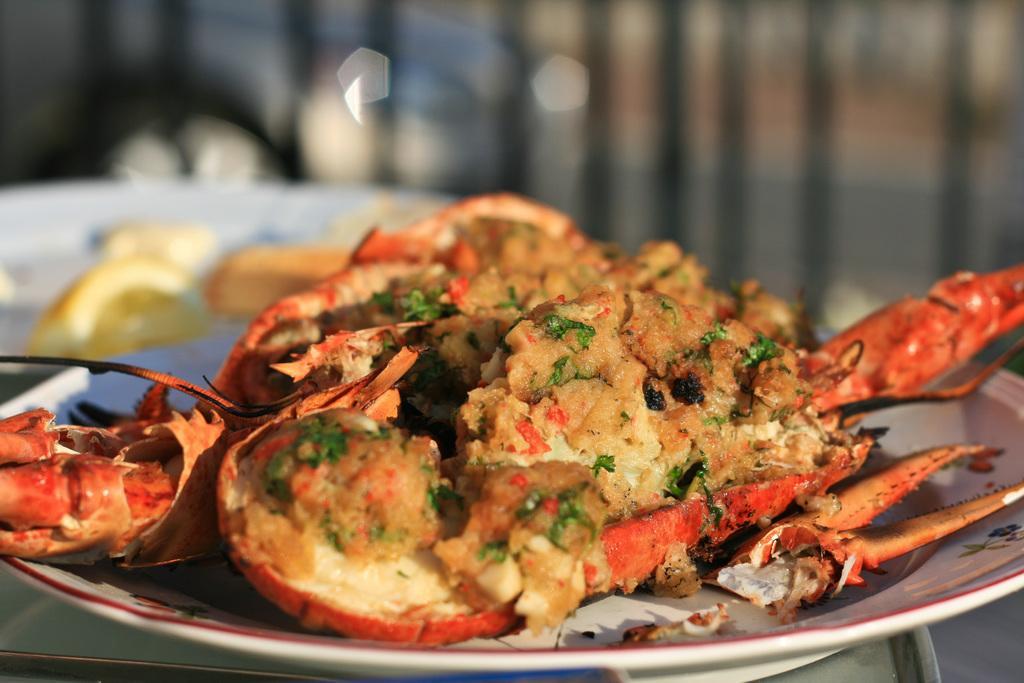How would you summarize this image in a sentence or two? In the front of the image I can see a plate and food. In the background of the image it is blurry. 